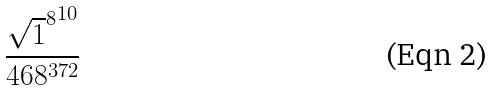<formula> <loc_0><loc_0><loc_500><loc_500>\frac { { \sqrt { 1 } ^ { 8 } } ^ { 1 0 } } { 4 6 8 ^ { 3 7 2 } }</formula> 